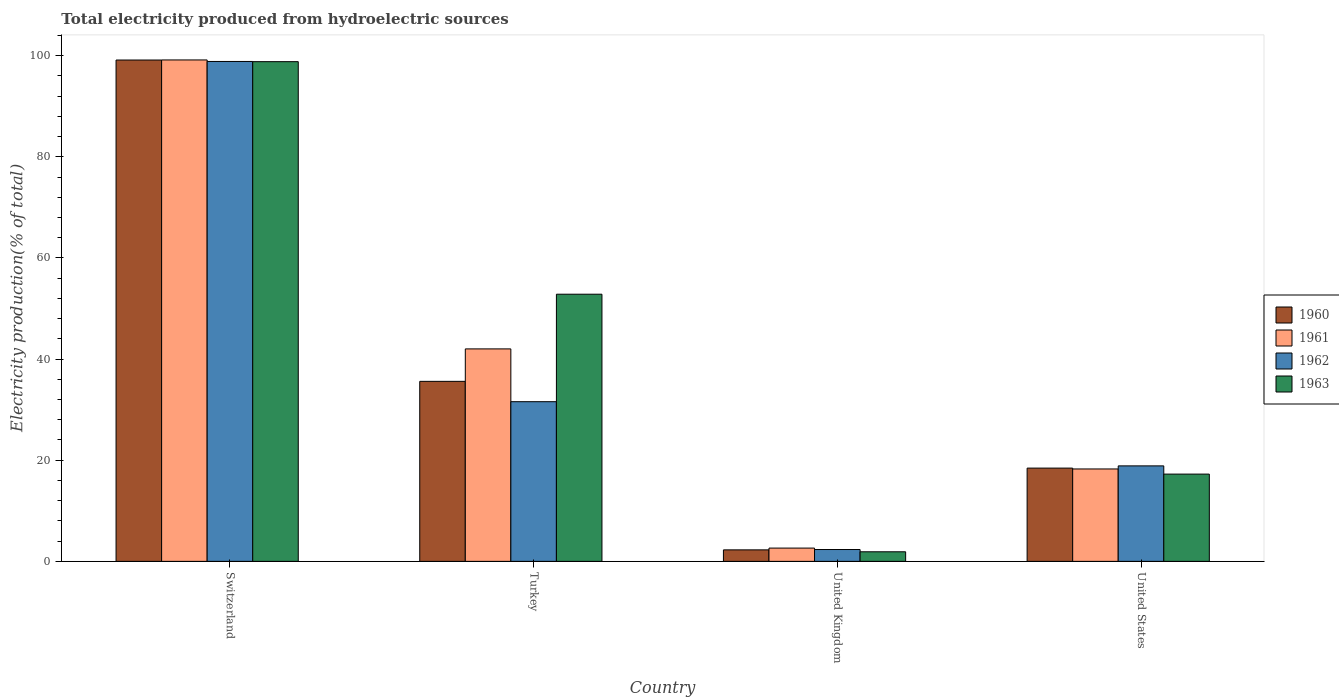Are the number of bars per tick equal to the number of legend labels?
Ensure brevity in your answer.  Yes. What is the label of the 1st group of bars from the left?
Your answer should be very brief. Switzerland. What is the total electricity produced in 1962 in United States?
Offer a very short reply. 18.88. Across all countries, what is the maximum total electricity produced in 1961?
Provide a succinct answer. 99.15. Across all countries, what is the minimum total electricity produced in 1962?
Offer a terse response. 2.34. In which country was the total electricity produced in 1963 maximum?
Make the answer very short. Switzerland. In which country was the total electricity produced in 1962 minimum?
Provide a succinct answer. United Kingdom. What is the total total electricity produced in 1960 in the graph?
Your response must be concise. 155.44. What is the difference between the total electricity produced in 1961 in Switzerland and that in United States?
Your response must be concise. 80.88. What is the difference between the total electricity produced in 1960 in United Kingdom and the total electricity produced in 1961 in United States?
Provide a short and direct response. -16. What is the average total electricity produced in 1963 per country?
Provide a succinct answer. 42.7. What is the difference between the total electricity produced of/in 1963 and total electricity produced of/in 1962 in United Kingdom?
Keep it short and to the point. -0.45. In how many countries, is the total electricity produced in 1960 greater than 4 %?
Your answer should be compact. 3. What is the ratio of the total electricity produced in 1960 in Switzerland to that in Turkey?
Offer a terse response. 2.78. Is the difference between the total electricity produced in 1963 in Turkey and United States greater than the difference between the total electricity produced in 1962 in Turkey and United States?
Your answer should be very brief. Yes. What is the difference between the highest and the second highest total electricity produced in 1963?
Provide a succinct answer. -81.55. What is the difference between the highest and the lowest total electricity produced in 1961?
Keep it short and to the point. 96.52. In how many countries, is the total electricity produced in 1961 greater than the average total electricity produced in 1961 taken over all countries?
Your answer should be very brief. 2. Is the sum of the total electricity produced in 1961 in Switzerland and United States greater than the maximum total electricity produced in 1963 across all countries?
Make the answer very short. Yes. Is it the case that in every country, the sum of the total electricity produced in 1960 and total electricity produced in 1961 is greater than the sum of total electricity produced in 1962 and total electricity produced in 1963?
Provide a succinct answer. No. How many bars are there?
Ensure brevity in your answer.  16. How many countries are there in the graph?
Ensure brevity in your answer.  4. Are the values on the major ticks of Y-axis written in scientific E-notation?
Give a very brief answer. No. Does the graph contain grids?
Offer a very short reply. No. Where does the legend appear in the graph?
Keep it short and to the point. Center right. How are the legend labels stacked?
Ensure brevity in your answer.  Vertical. What is the title of the graph?
Your response must be concise. Total electricity produced from hydroelectric sources. Does "1962" appear as one of the legend labels in the graph?
Your answer should be very brief. Yes. What is the label or title of the Y-axis?
Ensure brevity in your answer.  Electricity production(% of total). What is the Electricity production(% of total) in 1960 in Switzerland?
Give a very brief answer. 99.13. What is the Electricity production(% of total) in 1961 in Switzerland?
Offer a terse response. 99.15. What is the Electricity production(% of total) of 1962 in Switzerland?
Your response must be concise. 98.85. What is the Electricity production(% of total) of 1963 in Switzerland?
Offer a terse response. 98.81. What is the Electricity production(% of total) in 1960 in Turkey?
Keep it short and to the point. 35.6. What is the Electricity production(% of total) of 1961 in Turkey?
Give a very brief answer. 42.01. What is the Electricity production(% of total) of 1962 in Turkey?
Your response must be concise. 31.57. What is the Electricity production(% of total) of 1963 in Turkey?
Keep it short and to the point. 52.82. What is the Electricity production(% of total) in 1960 in United Kingdom?
Provide a succinct answer. 2.27. What is the Electricity production(% of total) of 1961 in United Kingdom?
Your answer should be compact. 2.63. What is the Electricity production(% of total) of 1962 in United Kingdom?
Your answer should be compact. 2.34. What is the Electricity production(% of total) of 1963 in United Kingdom?
Your answer should be compact. 1.89. What is the Electricity production(% of total) in 1960 in United States?
Ensure brevity in your answer.  18.44. What is the Electricity production(% of total) in 1961 in United States?
Offer a very short reply. 18.27. What is the Electricity production(% of total) in 1962 in United States?
Your answer should be very brief. 18.88. What is the Electricity production(% of total) of 1963 in United States?
Your answer should be compact. 17.26. Across all countries, what is the maximum Electricity production(% of total) in 1960?
Provide a succinct answer. 99.13. Across all countries, what is the maximum Electricity production(% of total) of 1961?
Offer a terse response. 99.15. Across all countries, what is the maximum Electricity production(% of total) of 1962?
Your response must be concise. 98.85. Across all countries, what is the maximum Electricity production(% of total) in 1963?
Provide a succinct answer. 98.81. Across all countries, what is the minimum Electricity production(% of total) in 1960?
Give a very brief answer. 2.27. Across all countries, what is the minimum Electricity production(% of total) in 1961?
Provide a short and direct response. 2.63. Across all countries, what is the minimum Electricity production(% of total) in 1962?
Offer a very short reply. 2.34. Across all countries, what is the minimum Electricity production(% of total) in 1963?
Your answer should be compact. 1.89. What is the total Electricity production(% of total) of 1960 in the graph?
Offer a very short reply. 155.44. What is the total Electricity production(% of total) of 1961 in the graph?
Offer a terse response. 162.06. What is the total Electricity production(% of total) in 1962 in the graph?
Your answer should be very brief. 151.64. What is the total Electricity production(% of total) of 1963 in the graph?
Provide a succinct answer. 170.78. What is the difference between the Electricity production(% of total) in 1960 in Switzerland and that in Turkey?
Ensure brevity in your answer.  63.54. What is the difference between the Electricity production(% of total) in 1961 in Switzerland and that in Turkey?
Your response must be concise. 57.13. What is the difference between the Electricity production(% of total) in 1962 in Switzerland and that in Turkey?
Offer a very short reply. 67.27. What is the difference between the Electricity production(% of total) in 1963 in Switzerland and that in Turkey?
Your answer should be compact. 45.98. What is the difference between the Electricity production(% of total) of 1960 in Switzerland and that in United Kingdom?
Your answer should be compact. 96.86. What is the difference between the Electricity production(% of total) in 1961 in Switzerland and that in United Kingdom?
Keep it short and to the point. 96.52. What is the difference between the Electricity production(% of total) in 1962 in Switzerland and that in United Kingdom?
Offer a terse response. 96.51. What is the difference between the Electricity production(% of total) of 1963 in Switzerland and that in United Kingdom?
Provide a succinct answer. 96.91. What is the difference between the Electricity production(% of total) in 1960 in Switzerland and that in United States?
Ensure brevity in your answer.  80.69. What is the difference between the Electricity production(% of total) of 1961 in Switzerland and that in United States?
Offer a very short reply. 80.88. What is the difference between the Electricity production(% of total) in 1962 in Switzerland and that in United States?
Your answer should be very brief. 79.97. What is the difference between the Electricity production(% of total) in 1963 in Switzerland and that in United States?
Ensure brevity in your answer.  81.55. What is the difference between the Electricity production(% of total) of 1960 in Turkey and that in United Kingdom?
Provide a succinct answer. 33.32. What is the difference between the Electricity production(% of total) in 1961 in Turkey and that in United Kingdom?
Your answer should be compact. 39.39. What is the difference between the Electricity production(% of total) in 1962 in Turkey and that in United Kingdom?
Your answer should be compact. 29.23. What is the difference between the Electricity production(% of total) in 1963 in Turkey and that in United Kingdom?
Your answer should be compact. 50.93. What is the difference between the Electricity production(% of total) of 1960 in Turkey and that in United States?
Provide a short and direct response. 17.16. What is the difference between the Electricity production(% of total) of 1961 in Turkey and that in United States?
Offer a terse response. 23.74. What is the difference between the Electricity production(% of total) of 1962 in Turkey and that in United States?
Keep it short and to the point. 12.69. What is the difference between the Electricity production(% of total) in 1963 in Turkey and that in United States?
Make the answer very short. 35.57. What is the difference between the Electricity production(% of total) of 1960 in United Kingdom and that in United States?
Provide a short and direct response. -16.17. What is the difference between the Electricity production(% of total) of 1961 in United Kingdom and that in United States?
Make the answer very short. -15.64. What is the difference between the Electricity production(% of total) of 1962 in United Kingdom and that in United States?
Your answer should be very brief. -16.54. What is the difference between the Electricity production(% of total) in 1963 in United Kingdom and that in United States?
Offer a terse response. -15.36. What is the difference between the Electricity production(% of total) in 1960 in Switzerland and the Electricity production(% of total) in 1961 in Turkey?
Ensure brevity in your answer.  57.12. What is the difference between the Electricity production(% of total) of 1960 in Switzerland and the Electricity production(% of total) of 1962 in Turkey?
Keep it short and to the point. 67.56. What is the difference between the Electricity production(% of total) of 1960 in Switzerland and the Electricity production(% of total) of 1963 in Turkey?
Offer a terse response. 46.31. What is the difference between the Electricity production(% of total) of 1961 in Switzerland and the Electricity production(% of total) of 1962 in Turkey?
Your answer should be very brief. 67.57. What is the difference between the Electricity production(% of total) in 1961 in Switzerland and the Electricity production(% of total) in 1963 in Turkey?
Provide a succinct answer. 46.32. What is the difference between the Electricity production(% of total) in 1962 in Switzerland and the Electricity production(% of total) in 1963 in Turkey?
Keep it short and to the point. 46.02. What is the difference between the Electricity production(% of total) of 1960 in Switzerland and the Electricity production(% of total) of 1961 in United Kingdom?
Offer a very short reply. 96.5. What is the difference between the Electricity production(% of total) of 1960 in Switzerland and the Electricity production(% of total) of 1962 in United Kingdom?
Your answer should be very brief. 96.79. What is the difference between the Electricity production(% of total) of 1960 in Switzerland and the Electricity production(% of total) of 1963 in United Kingdom?
Provide a succinct answer. 97.24. What is the difference between the Electricity production(% of total) of 1961 in Switzerland and the Electricity production(% of total) of 1962 in United Kingdom?
Offer a terse response. 96.81. What is the difference between the Electricity production(% of total) of 1961 in Switzerland and the Electricity production(% of total) of 1963 in United Kingdom?
Your answer should be very brief. 97.25. What is the difference between the Electricity production(% of total) of 1962 in Switzerland and the Electricity production(% of total) of 1963 in United Kingdom?
Keep it short and to the point. 96.95. What is the difference between the Electricity production(% of total) in 1960 in Switzerland and the Electricity production(% of total) in 1961 in United States?
Your answer should be very brief. 80.86. What is the difference between the Electricity production(% of total) in 1960 in Switzerland and the Electricity production(% of total) in 1962 in United States?
Offer a very short reply. 80.25. What is the difference between the Electricity production(% of total) in 1960 in Switzerland and the Electricity production(% of total) in 1963 in United States?
Provide a succinct answer. 81.88. What is the difference between the Electricity production(% of total) in 1961 in Switzerland and the Electricity production(% of total) in 1962 in United States?
Offer a terse response. 80.27. What is the difference between the Electricity production(% of total) in 1961 in Switzerland and the Electricity production(% of total) in 1963 in United States?
Provide a succinct answer. 81.89. What is the difference between the Electricity production(% of total) in 1962 in Switzerland and the Electricity production(% of total) in 1963 in United States?
Offer a very short reply. 81.59. What is the difference between the Electricity production(% of total) in 1960 in Turkey and the Electricity production(% of total) in 1961 in United Kingdom?
Make the answer very short. 32.97. What is the difference between the Electricity production(% of total) in 1960 in Turkey and the Electricity production(% of total) in 1962 in United Kingdom?
Keep it short and to the point. 33.26. What is the difference between the Electricity production(% of total) in 1960 in Turkey and the Electricity production(% of total) in 1963 in United Kingdom?
Offer a terse response. 33.7. What is the difference between the Electricity production(% of total) in 1961 in Turkey and the Electricity production(% of total) in 1962 in United Kingdom?
Ensure brevity in your answer.  39.67. What is the difference between the Electricity production(% of total) in 1961 in Turkey and the Electricity production(% of total) in 1963 in United Kingdom?
Give a very brief answer. 40.12. What is the difference between the Electricity production(% of total) in 1962 in Turkey and the Electricity production(% of total) in 1963 in United Kingdom?
Your answer should be very brief. 29.68. What is the difference between the Electricity production(% of total) in 1960 in Turkey and the Electricity production(% of total) in 1961 in United States?
Provide a succinct answer. 17.32. What is the difference between the Electricity production(% of total) of 1960 in Turkey and the Electricity production(% of total) of 1962 in United States?
Provide a succinct answer. 16.71. What is the difference between the Electricity production(% of total) in 1960 in Turkey and the Electricity production(% of total) in 1963 in United States?
Your response must be concise. 18.34. What is the difference between the Electricity production(% of total) of 1961 in Turkey and the Electricity production(% of total) of 1962 in United States?
Your answer should be compact. 23.13. What is the difference between the Electricity production(% of total) of 1961 in Turkey and the Electricity production(% of total) of 1963 in United States?
Offer a very short reply. 24.76. What is the difference between the Electricity production(% of total) in 1962 in Turkey and the Electricity production(% of total) in 1963 in United States?
Your answer should be compact. 14.32. What is the difference between the Electricity production(% of total) in 1960 in United Kingdom and the Electricity production(% of total) in 1961 in United States?
Make the answer very short. -16. What is the difference between the Electricity production(% of total) in 1960 in United Kingdom and the Electricity production(% of total) in 1962 in United States?
Make the answer very short. -16.61. What is the difference between the Electricity production(% of total) of 1960 in United Kingdom and the Electricity production(% of total) of 1963 in United States?
Your answer should be compact. -14.98. What is the difference between the Electricity production(% of total) in 1961 in United Kingdom and the Electricity production(% of total) in 1962 in United States?
Your answer should be very brief. -16.25. What is the difference between the Electricity production(% of total) in 1961 in United Kingdom and the Electricity production(% of total) in 1963 in United States?
Your response must be concise. -14.63. What is the difference between the Electricity production(% of total) of 1962 in United Kingdom and the Electricity production(% of total) of 1963 in United States?
Offer a terse response. -14.92. What is the average Electricity production(% of total) of 1960 per country?
Give a very brief answer. 38.86. What is the average Electricity production(% of total) in 1961 per country?
Your answer should be very brief. 40.51. What is the average Electricity production(% of total) of 1962 per country?
Your answer should be compact. 37.91. What is the average Electricity production(% of total) of 1963 per country?
Offer a terse response. 42.7. What is the difference between the Electricity production(% of total) in 1960 and Electricity production(% of total) in 1961 in Switzerland?
Your response must be concise. -0.02. What is the difference between the Electricity production(% of total) in 1960 and Electricity production(% of total) in 1962 in Switzerland?
Offer a very short reply. 0.28. What is the difference between the Electricity production(% of total) in 1960 and Electricity production(% of total) in 1963 in Switzerland?
Your answer should be compact. 0.32. What is the difference between the Electricity production(% of total) in 1961 and Electricity production(% of total) in 1962 in Switzerland?
Offer a terse response. 0.3. What is the difference between the Electricity production(% of total) in 1961 and Electricity production(% of total) in 1963 in Switzerland?
Your answer should be compact. 0.34. What is the difference between the Electricity production(% of total) in 1962 and Electricity production(% of total) in 1963 in Switzerland?
Your answer should be compact. 0.04. What is the difference between the Electricity production(% of total) in 1960 and Electricity production(% of total) in 1961 in Turkey?
Your answer should be very brief. -6.42. What is the difference between the Electricity production(% of total) in 1960 and Electricity production(% of total) in 1962 in Turkey?
Keep it short and to the point. 4.02. What is the difference between the Electricity production(% of total) of 1960 and Electricity production(% of total) of 1963 in Turkey?
Your response must be concise. -17.23. What is the difference between the Electricity production(% of total) in 1961 and Electricity production(% of total) in 1962 in Turkey?
Ensure brevity in your answer.  10.44. What is the difference between the Electricity production(% of total) in 1961 and Electricity production(% of total) in 1963 in Turkey?
Keep it short and to the point. -10.81. What is the difference between the Electricity production(% of total) of 1962 and Electricity production(% of total) of 1963 in Turkey?
Your response must be concise. -21.25. What is the difference between the Electricity production(% of total) in 1960 and Electricity production(% of total) in 1961 in United Kingdom?
Offer a very short reply. -0.35. What is the difference between the Electricity production(% of total) of 1960 and Electricity production(% of total) of 1962 in United Kingdom?
Provide a short and direct response. -0.07. What is the difference between the Electricity production(% of total) of 1960 and Electricity production(% of total) of 1963 in United Kingdom?
Your answer should be very brief. 0.38. What is the difference between the Electricity production(% of total) in 1961 and Electricity production(% of total) in 1962 in United Kingdom?
Keep it short and to the point. 0.29. What is the difference between the Electricity production(% of total) in 1961 and Electricity production(% of total) in 1963 in United Kingdom?
Give a very brief answer. 0.73. What is the difference between the Electricity production(% of total) in 1962 and Electricity production(% of total) in 1963 in United Kingdom?
Offer a very short reply. 0.45. What is the difference between the Electricity production(% of total) in 1960 and Electricity production(% of total) in 1961 in United States?
Provide a succinct answer. 0.17. What is the difference between the Electricity production(% of total) of 1960 and Electricity production(% of total) of 1962 in United States?
Your answer should be compact. -0.44. What is the difference between the Electricity production(% of total) in 1960 and Electricity production(% of total) in 1963 in United States?
Ensure brevity in your answer.  1.18. What is the difference between the Electricity production(% of total) in 1961 and Electricity production(% of total) in 1962 in United States?
Your answer should be very brief. -0.61. What is the difference between the Electricity production(% of total) in 1961 and Electricity production(% of total) in 1963 in United States?
Your answer should be compact. 1.02. What is the difference between the Electricity production(% of total) in 1962 and Electricity production(% of total) in 1963 in United States?
Keep it short and to the point. 1.63. What is the ratio of the Electricity production(% of total) in 1960 in Switzerland to that in Turkey?
Offer a very short reply. 2.79. What is the ratio of the Electricity production(% of total) of 1961 in Switzerland to that in Turkey?
Provide a succinct answer. 2.36. What is the ratio of the Electricity production(% of total) of 1962 in Switzerland to that in Turkey?
Make the answer very short. 3.13. What is the ratio of the Electricity production(% of total) of 1963 in Switzerland to that in Turkey?
Provide a short and direct response. 1.87. What is the ratio of the Electricity production(% of total) of 1960 in Switzerland to that in United Kingdom?
Ensure brevity in your answer.  43.61. What is the ratio of the Electricity production(% of total) in 1961 in Switzerland to that in United Kingdom?
Keep it short and to the point. 37.75. What is the ratio of the Electricity production(% of total) of 1962 in Switzerland to that in United Kingdom?
Offer a very short reply. 42.24. What is the ratio of the Electricity production(% of total) of 1963 in Switzerland to that in United Kingdom?
Give a very brief answer. 52.18. What is the ratio of the Electricity production(% of total) in 1960 in Switzerland to that in United States?
Give a very brief answer. 5.38. What is the ratio of the Electricity production(% of total) in 1961 in Switzerland to that in United States?
Provide a short and direct response. 5.43. What is the ratio of the Electricity production(% of total) of 1962 in Switzerland to that in United States?
Keep it short and to the point. 5.24. What is the ratio of the Electricity production(% of total) of 1963 in Switzerland to that in United States?
Keep it short and to the point. 5.73. What is the ratio of the Electricity production(% of total) of 1960 in Turkey to that in United Kingdom?
Your answer should be very brief. 15.66. What is the ratio of the Electricity production(% of total) in 1961 in Turkey to that in United Kingdom?
Keep it short and to the point. 16. What is the ratio of the Electricity production(% of total) of 1962 in Turkey to that in United Kingdom?
Offer a very short reply. 13.49. What is the ratio of the Electricity production(% of total) of 1963 in Turkey to that in United Kingdom?
Ensure brevity in your answer.  27.9. What is the ratio of the Electricity production(% of total) in 1960 in Turkey to that in United States?
Make the answer very short. 1.93. What is the ratio of the Electricity production(% of total) in 1961 in Turkey to that in United States?
Your response must be concise. 2.3. What is the ratio of the Electricity production(% of total) of 1962 in Turkey to that in United States?
Your answer should be compact. 1.67. What is the ratio of the Electricity production(% of total) in 1963 in Turkey to that in United States?
Provide a short and direct response. 3.06. What is the ratio of the Electricity production(% of total) in 1960 in United Kingdom to that in United States?
Your response must be concise. 0.12. What is the ratio of the Electricity production(% of total) of 1961 in United Kingdom to that in United States?
Make the answer very short. 0.14. What is the ratio of the Electricity production(% of total) of 1962 in United Kingdom to that in United States?
Ensure brevity in your answer.  0.12. What is the ratio of the Electricity production(% of total) in 1963 in United Kingdom to that in United States?
Your response must be concise. 0.11. What is the difference between the highest and the second highest Electricity production(% of total) in 1960?
Provide a short and direct response. 63.54. What is the difference between the highest and the second highest Electricity production(% of total) in 1961?
Make the answer very short. 57.13. What is the difference between the highest and the second highest Electricity production(% of total) of 1962?
Ensure brevity in your answer.  67.27. What is the difference between the highest and the second highest Electricity production(% of total) in 1963?
Your answer should be compact. 45.98. What is the difference between the highest and the lowest Electricity production(% of total) of 1960?
Offer a very short reply. 96.86. What is the difference between the highest and the lowest Electricity production(% of total) of 1961?
Provide a succinct answer. 96.52. What is the difference between the highest and the lowest Electricity production(% of total) in 1962?
Keep it short and to the point. 96.51. What is the difference between the highest and the lowest Electricity production(% of total) of 1963?
Offer a very short reply. 96.91. 